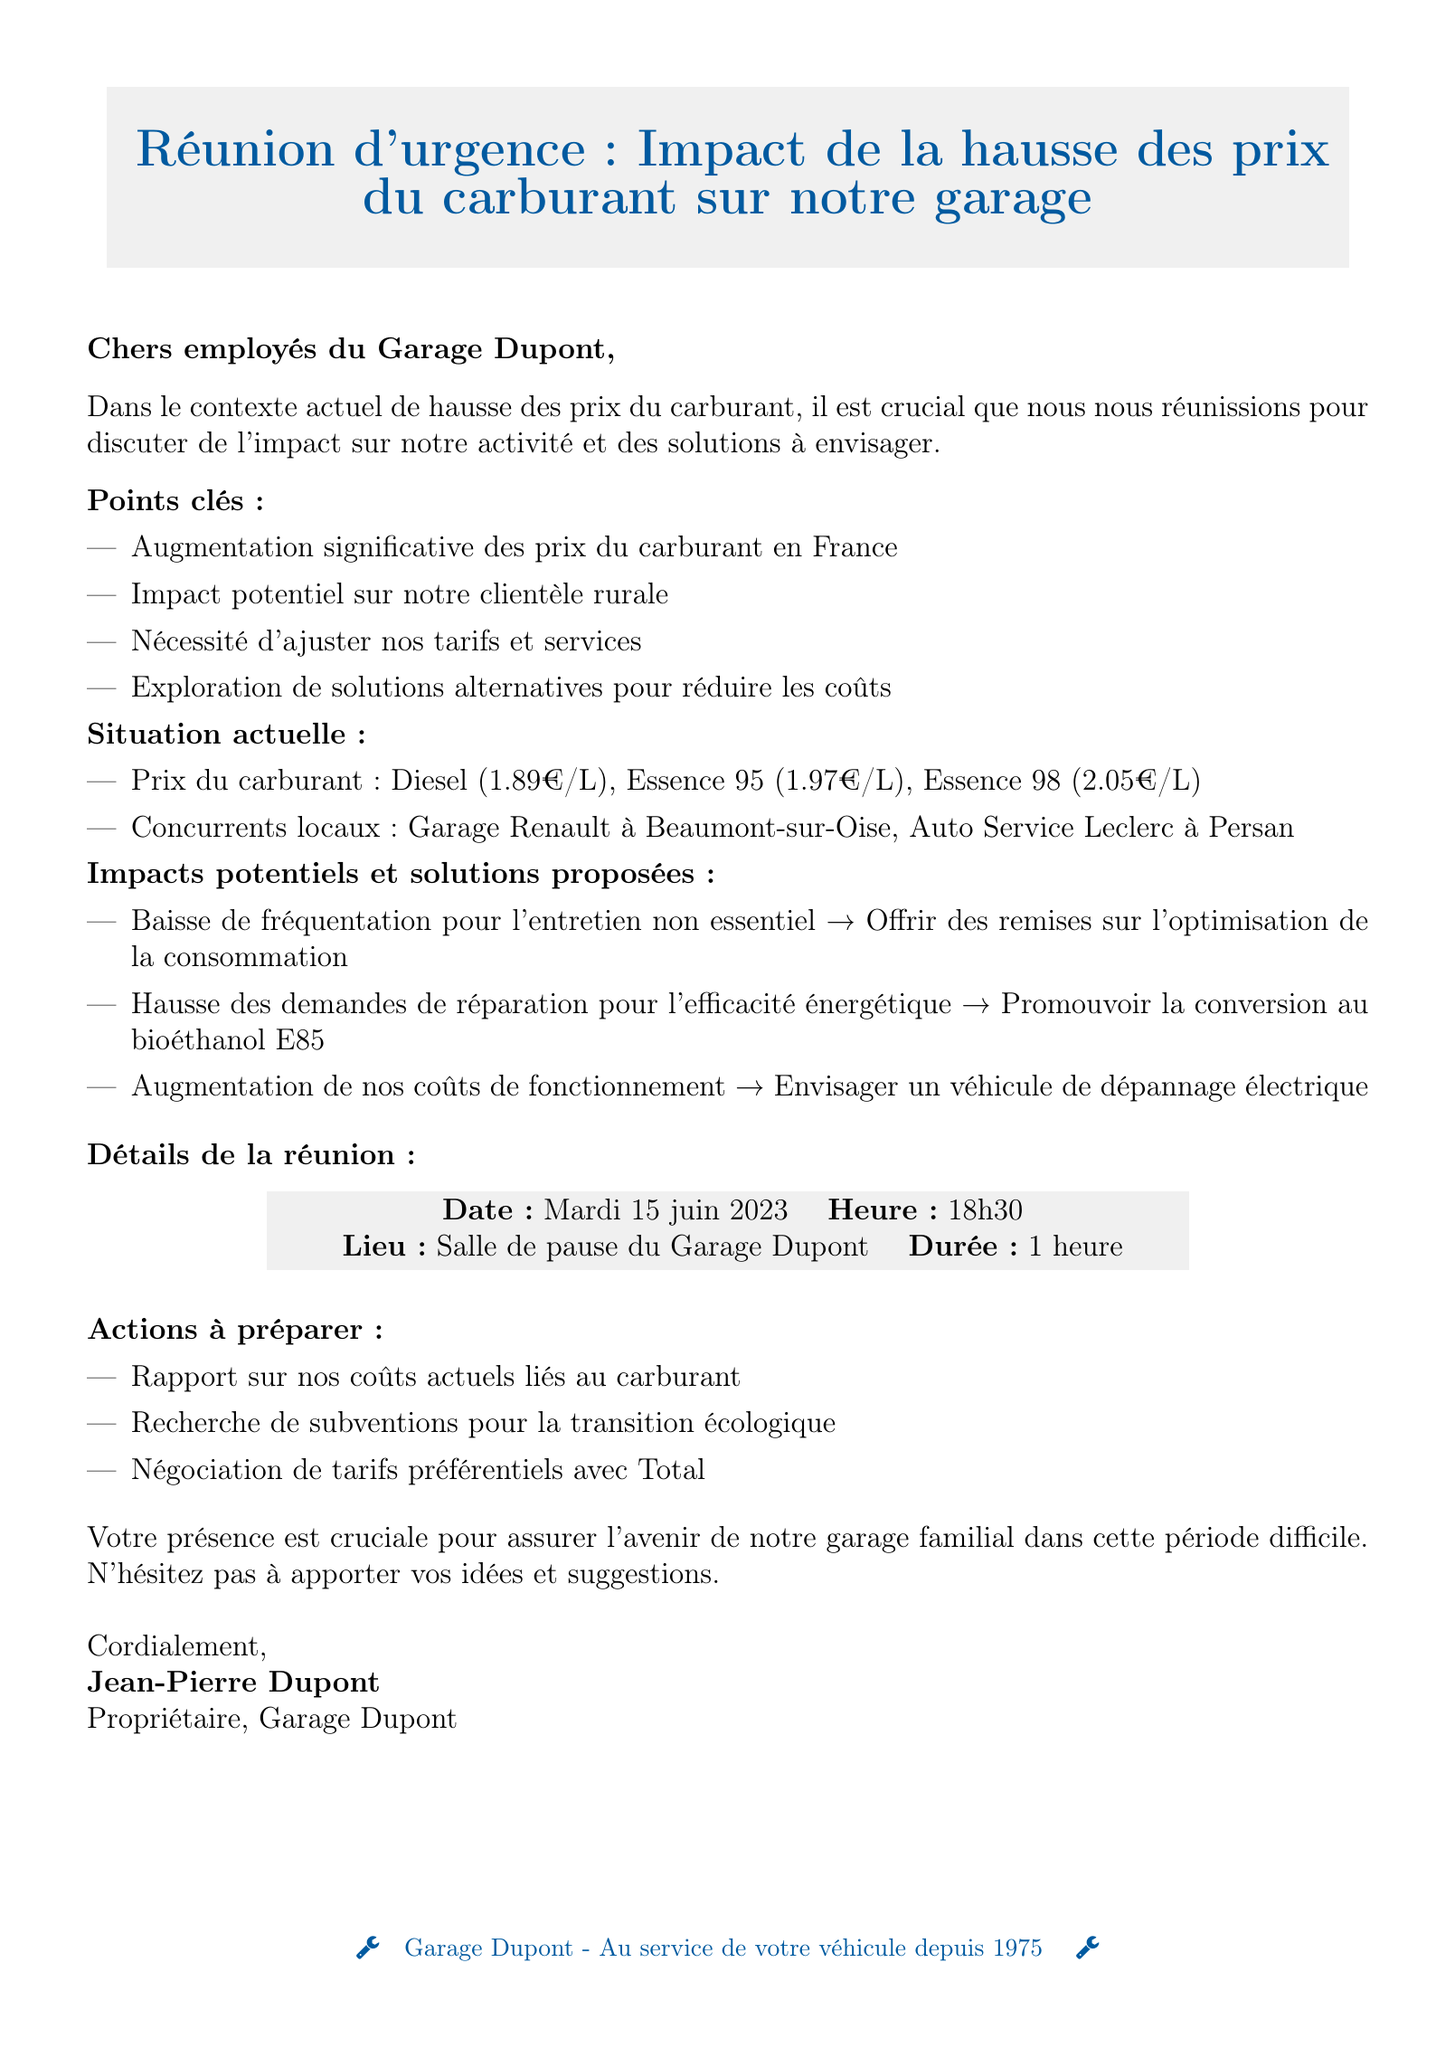Quelle est la date de la réunion ? La date de la réunion est précisée dans la section "Détails de la réunion".
Answer: Mardi 15 juin 2023 Quel est le prix du diesel par litre ? Le prix du diesel est mentionné dans la section "Situation actuelle".
Answer: 1.89€ par litre Quels sont les concurrents locaux mentionnés ? Les concurrents locaux sont listés dans la section "Situation actuelle".
Answer: Garage Renault à Beaumont-sur-Oise, Auto Service Leclerc à Persan Quels types de solutions sont proposées ? Les solutions proposées sont énumérées sous "Impacts potentiels et solutions proposées".
Answer: Offrir des remises sur les services d'optimisation de la consommation de carburant, promouvoir la conversion au bioéthanol E85, envisager l'achat d'un véhicule de dépannage électrique, renforcer nos partenariats avec les agriculteurs locaux pour des services spécialisés Combien de temps durera la réunion ? La durée de la réunion est indiquée dans la section "Détails de la réunion".
Answer: 1 heure Qui a signé le mémo ? Le signataire du mémo est mentionné à la fin du document.
Answer: Jean-Pierre Dupont 